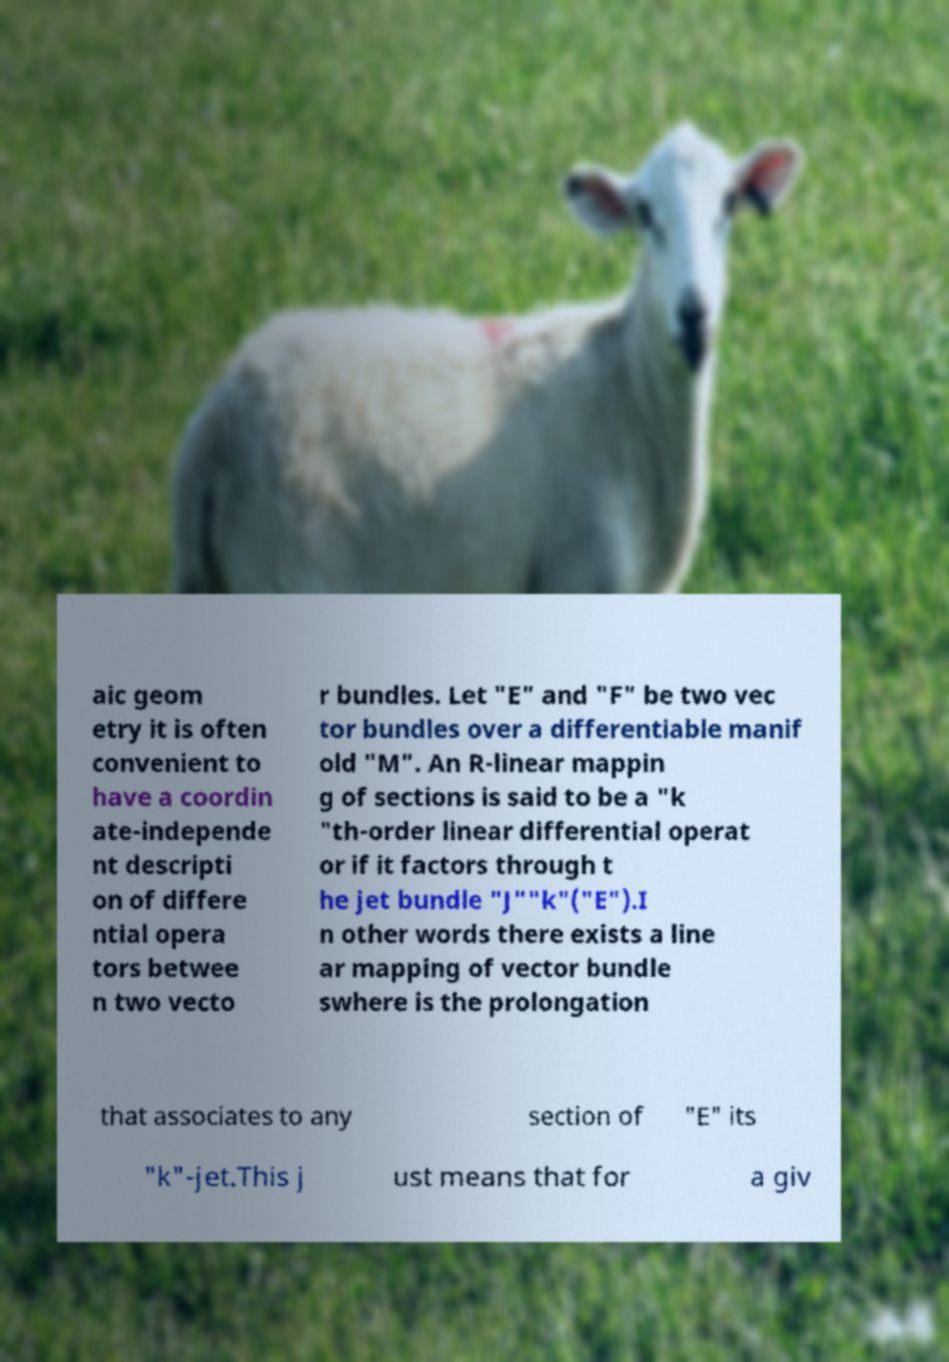What messages or text are displayed in this image? I need them in a readable, typed format. aic geom etry it is often convenient to have a coordin ate-independe nt descripti on of differe ntial opera tors betwee n two vecto r bundles. Let "E" and "F" be two vec tor bundles over a differentiable manif old "M". An R-linear mappin g of sections is said to be a "k "th-order linear differential operat or if it factors through t he jet bundle "J""k"("E").I n other words there exists a line ar mapping of vector bundle swhere is the prolongation that associates to any section of "E" its "k"-jet.This j ust means that for a giv 